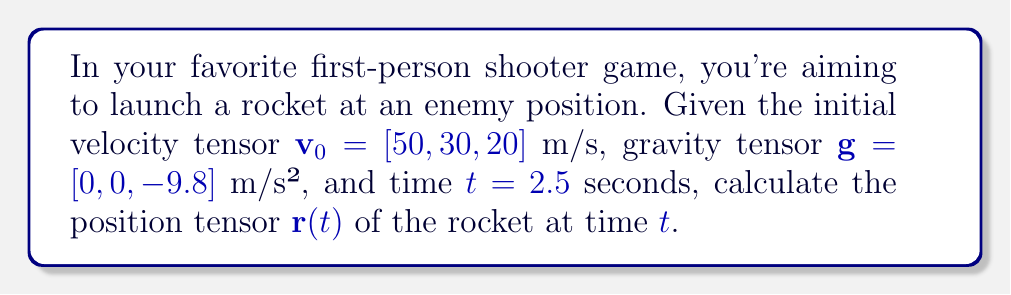Solve this math problem. To solve this problem, we'll use the tensor equation for projectile motion in 3D:

$$\mathbf{r}(t) = \mathbf{r}_0 + \mathbf{v}_0 t + \frac{1}{2}\mathbf{g}t^2$$

Where:
$\mathbf{r}(t)$ is the position tensor at time $t$
$\mathbf{r}_0$ is the initial position tensor (assumed to be $[0, 0, 0]$ in this case)
$\mathbf{v}_0$ is the initial velocity tensor
$\mathbf{g}$ is the gravity tensor
$t$ is the time

Step 1: Substitute the given values into the equation:
$$\mathbf{r}(t) = [0, 0, 0] + [50, 30, 20](2.5) + \frac{1}{2}[0, 0, -9.8](2.5)^2$$

Step 2: Calculate $\mathbf{v}_0 t$:
$$[50, 30, 20](2.5) = [125, 75, 50]$$

Step 3: Calculate $\frac{1}{2}\mathbf{g}t^2$:
$$\frac{1}{2}[0, 0, -9.8](2.5)^2 = [0, 0, -30.625]$$

Step 4: Sum up all components:
$$\mathbf{r}(t) = [0, 0, 0] + [125, 75, 50] + [0, 0, -30.625]$$

Step 5: Simplify:
$$\mathbf{r}(t) = [125, 75, 19.375]$$
Answer: $\mathbf{r}(2.5) = [125, 75, 19.375]$ m 